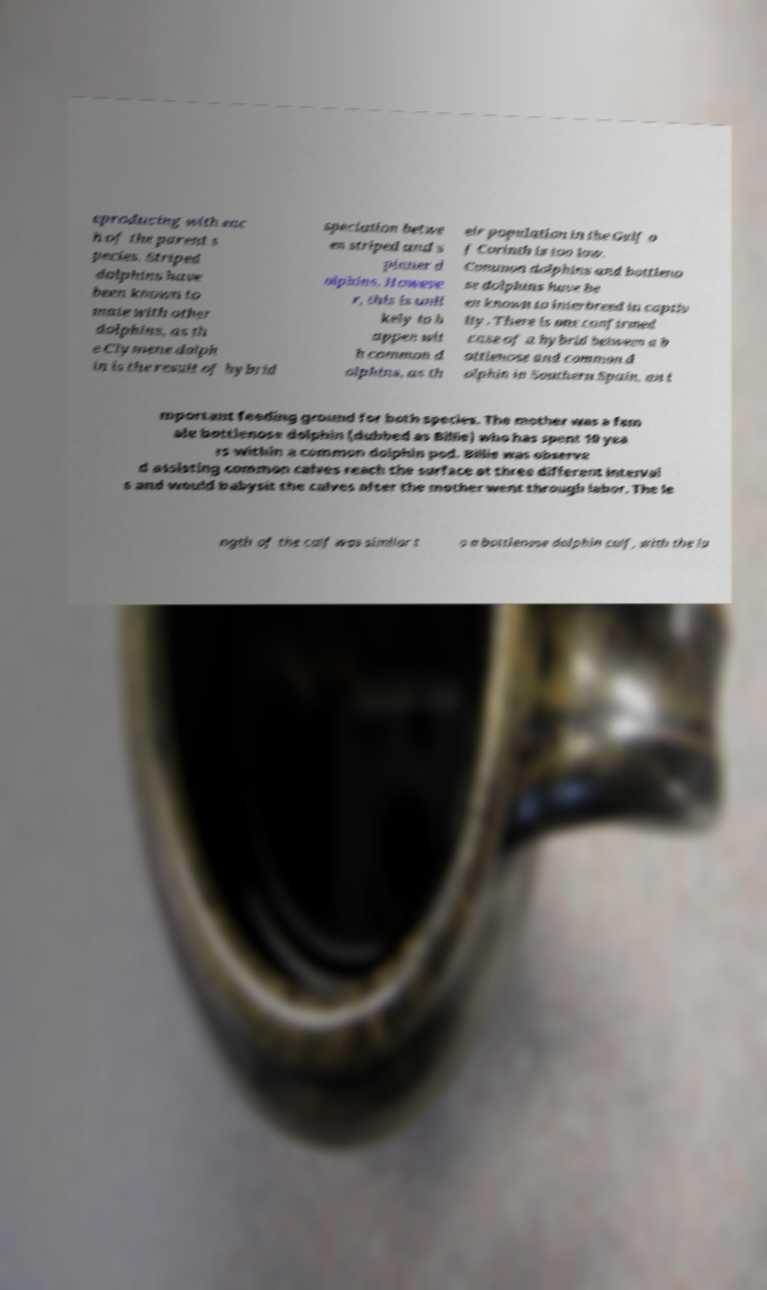Please read and relay the text visible in this image. What does it say? eproducing with eac h of the parent s pecies. Striped dolphins have been known to mate with other dolphins, as th e Clymene dolph in is the result of hybrid speciation betwe en striped and s pinner d olphins. Howeve r, this is unli kely to h appen wit h common d olphins, as th eir population in the Gulf o f Corinth is too low. Common dolphins and bottleno se dolphins have be en known to interbreed in captiv ity. There is one confirmed case of a hybrid between a b ottlenose and common d olphin in Southern Spain, an i mportant feeding ground for both species. The mother was a fem ale bottlenose dolphin (dubbed as Billie) who has spent 10 yea rs within a common dolphin pod. Billie was observe d assisting common calves reach the surface at three different interval s and would babysit the calves after the mother went through labor. The le ngth of the calf was similar t o a bottlenose dolphin calf, with the la 